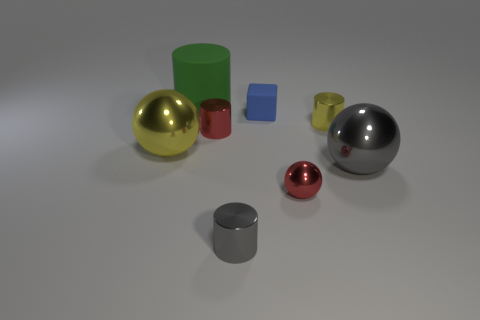Does the small cylinder in front of the big yellow thing have the same material as the tiny yellow cylinder?
Provide a short and direct response. Yes. There is a thing that is both to the left of the small gray metal thing and in front of the red metal cylinder; how big is it?
Offer a terse response. Large. What is the color of the small matte cube?
Your answer should be very brief. Blue. How many matte cubes are there?
Ensure brevity in your answer.  1. How many tiny shiny cylinders have the same color as the big rubber object?
Make the answer very short. 0. Do the gray metal object that is to the right of the small yellow shiny cylinder and the yellow metal thing that is to the right of the big cylinder have the same shape?
Offer a very short reply. No. What color is the small cylinder that is left of the tiny cylinder in front of the gray object that is on the right side of the tiny yellow shiny object?
Offer a very short reply. Red. What color is the large shiny object in front of the large yellow object?
Give a very brief answer. Gray. There is a metallic ball that is the same size as the blue rubber thing; what color is it?
Keep it short and to the point. Red. Do the blue matte block and the yellow metal cylinder have the same size?
Provide a short and direct response. Yes. 